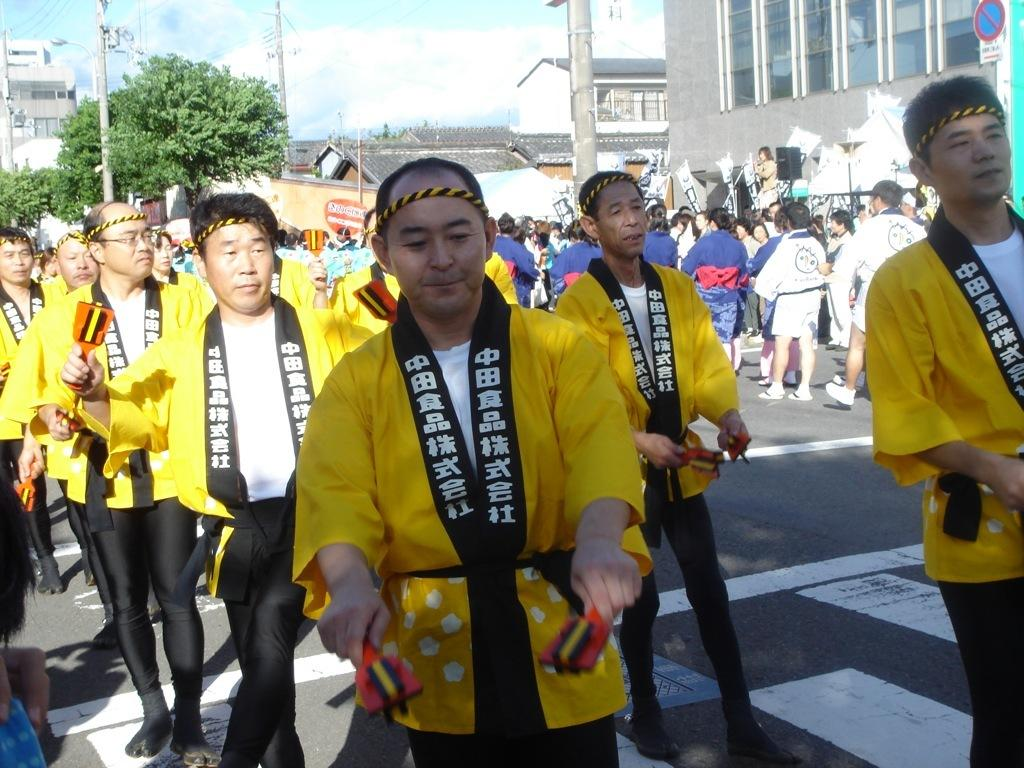What can be seen on the road in the image? There are a lot of people on the road in the image. What type of structures are present in the image? There are buildings and houses in the image. What type of vegetation can be seen in the image? There are trees in the image. What else can be seen in the image besides people, buildings, houses, and trees? There are poles in the image. How many visitors can be seen in the image? There is no mention of visitors in the image; it only shows people on the road. What type of patch is visible on the trees in the image? There is no patch visible on the trees in the image; only trees are mentioned. 